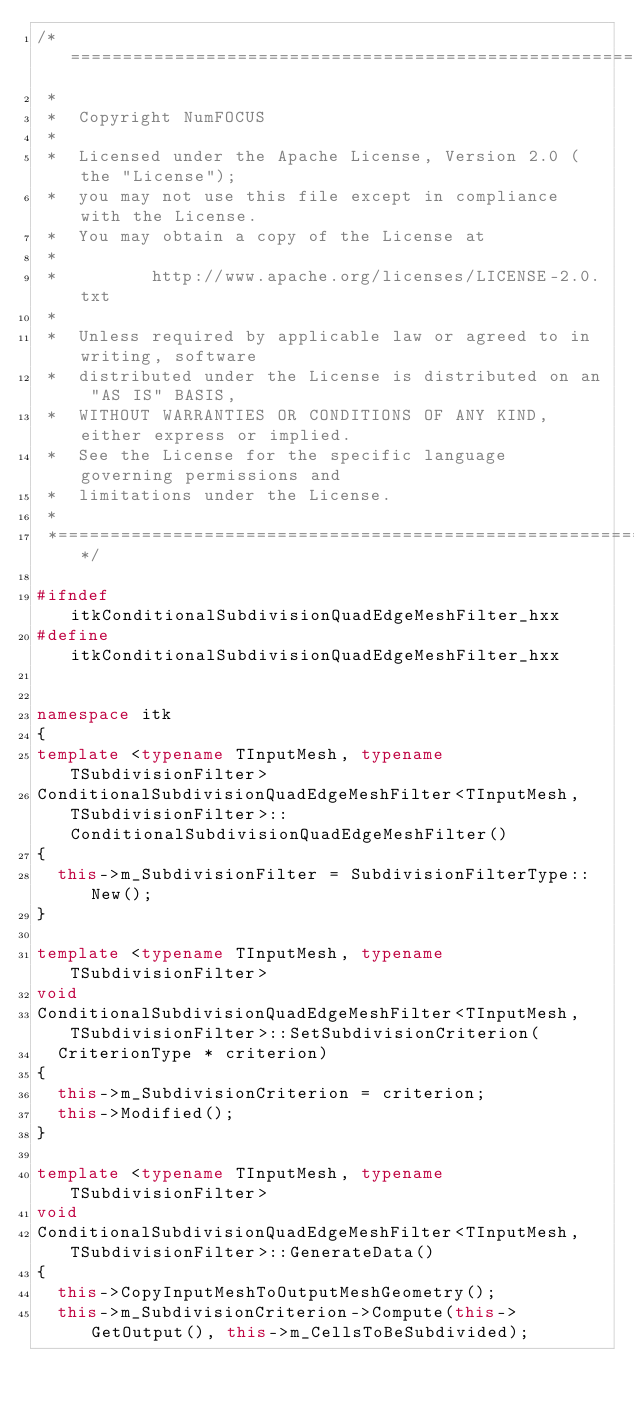Convert code to text. <code><loc_0><loc_0><loc_500><loc_500><_C++_>/*=========================================================================
 *
 *  Copyright NumFOCUS
 *
 *  Licensed under the Apache License, Version 2.0 (the "License");
 *  you may not use this file except in compliance with the License.
 *  You may obtain a copy of the License at
 *
 *         http://www.apache.org/licenses/LICENSE-2.0.txt
 *
 *  Unless required by applicable law or agreed to in writing, software
 *  distributed under the License is distributed on an "AS IS" BASIS,
 *  WITHOUT WARRANTIES OR CONDITIONS OF ANY KIND, either express or implied.
 *  See the License for the specific language governing permissions and
 *  limitations under the License.
 *
 *=========================================================================*/

#ifndef itkConditionalSubdivisionQuadEdgeMeshFilter_hxx
#define itkConditionalSubdivisionQuadEdgeMeshFilter_hxx


namespace itk
{
template <typename TInputMesh, typename TSubdivisionFilter>
ConditionalSubdivisionQuadEdgeMeshFilter<TInputMesh, TSubdivisionFilter>::ConditionalSubdivisionQuadEdgeMeshFilter()
{
  this->m_SubdivisionFilter = SubdivisionFilterType::New();
}

template <typename TInputMesh, typename TSubdivisionFilter>
void
ConditionalSubdivisionQuadEdgeMeshFilter<TInputMesh, TSubdivisionFilter>::SetSubdivisionCriterion(
  CriterionType * criterion)
{
  this->m_SubdivisionCriterion = criterion;
  this->Modified();
}

template <typename TInputMesh, typename TSubdivisionFilter>
void
ConditionalSubdivisionQuadEdgeMeshFilter<TInputMesh, TSubdivisionFilter>::GenerateData()
{
  this->CopyInputMeshToOutputMeshGeometry();
  this->m_SubdivisionCriterion->Compute(this->GetOutput(), this->m_CellsToBeSubdivided);
</code> 